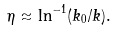<formula> <loc_0><loc_0><loc_500><loc_500>\eta \approx \ln ^ { - 1 } ( k _ { 0 } / k ) .</formula> 